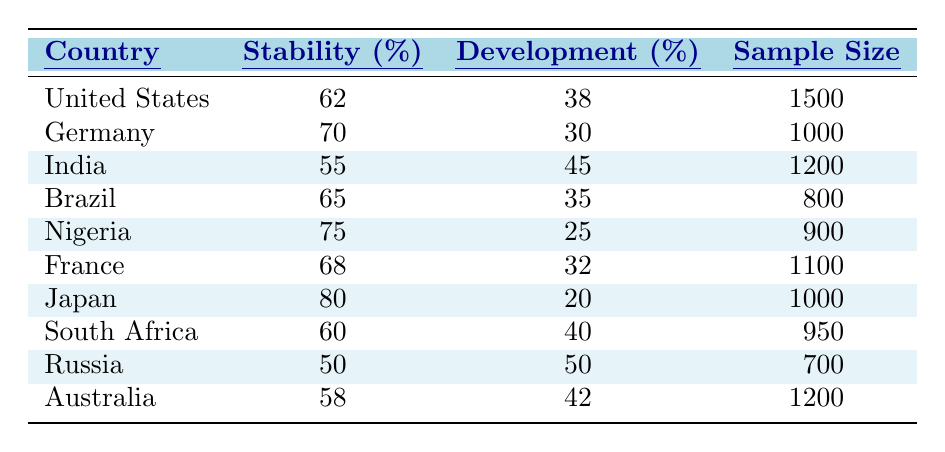What percentage of people in Germany prefer stability over development? According to the table, Germany has a stability preference of 70%.
Answer: 70% Which country has the lowest stability preference? In the table, Russia has a stability preference of 50%, which is the lowest among the countries listed.
Answer: Russia What is the difference between the stability preference and development preference in Brazil? Brazil's stability preference is 65% and the development preference is 35%. The difference is 65 - 35 = 30%.
Answer: 30% What is the average stability preference among all countries listed? To find the average stability preference, sum the stability preferences (62 + 70 + 55 + 65 + 75 + 68 + 80 + 60 + 50 + 58 =  675) and divide by the number of countries (10), which gives 675 / 10 = 67.5%.
Answer: 67.5% Is it true that more than 70% of respondents in Japan prefer stability over development? Japan has a stability preference of 80%, which is indeed greater than 70%.
Answer: Yes How many countries in total have a stability preference of over 60%? The countries with a stability preference over 60% are the United States, Germany, Brazil, Nigeria, France, and Japan. A total of 6 countries exceed this threshold.
Answer: 6 If you combine the stability preferences of India, Nigeria, and Japan, what is the total? The stability preferences for India (55%), Nigeria (75%), and Japan (80%) add up to 55 + 75 + 80 = 210%.
Answer: 210% What percentage of respondents in Russia prioritized economic development? Russia has a development preference of 50%, indicating equal prioritization of stability and development.
Answer: 50% Which country indicates the highest preference for stability, and what is the percentage? Japan is the country with the highest stability preference at 80%.
Answer: Japan, 80% Is there any country where the stability and development preferences are equal? Yes, Russia shows an equal preference with 50% for both stability and development.
Answer: Yes 